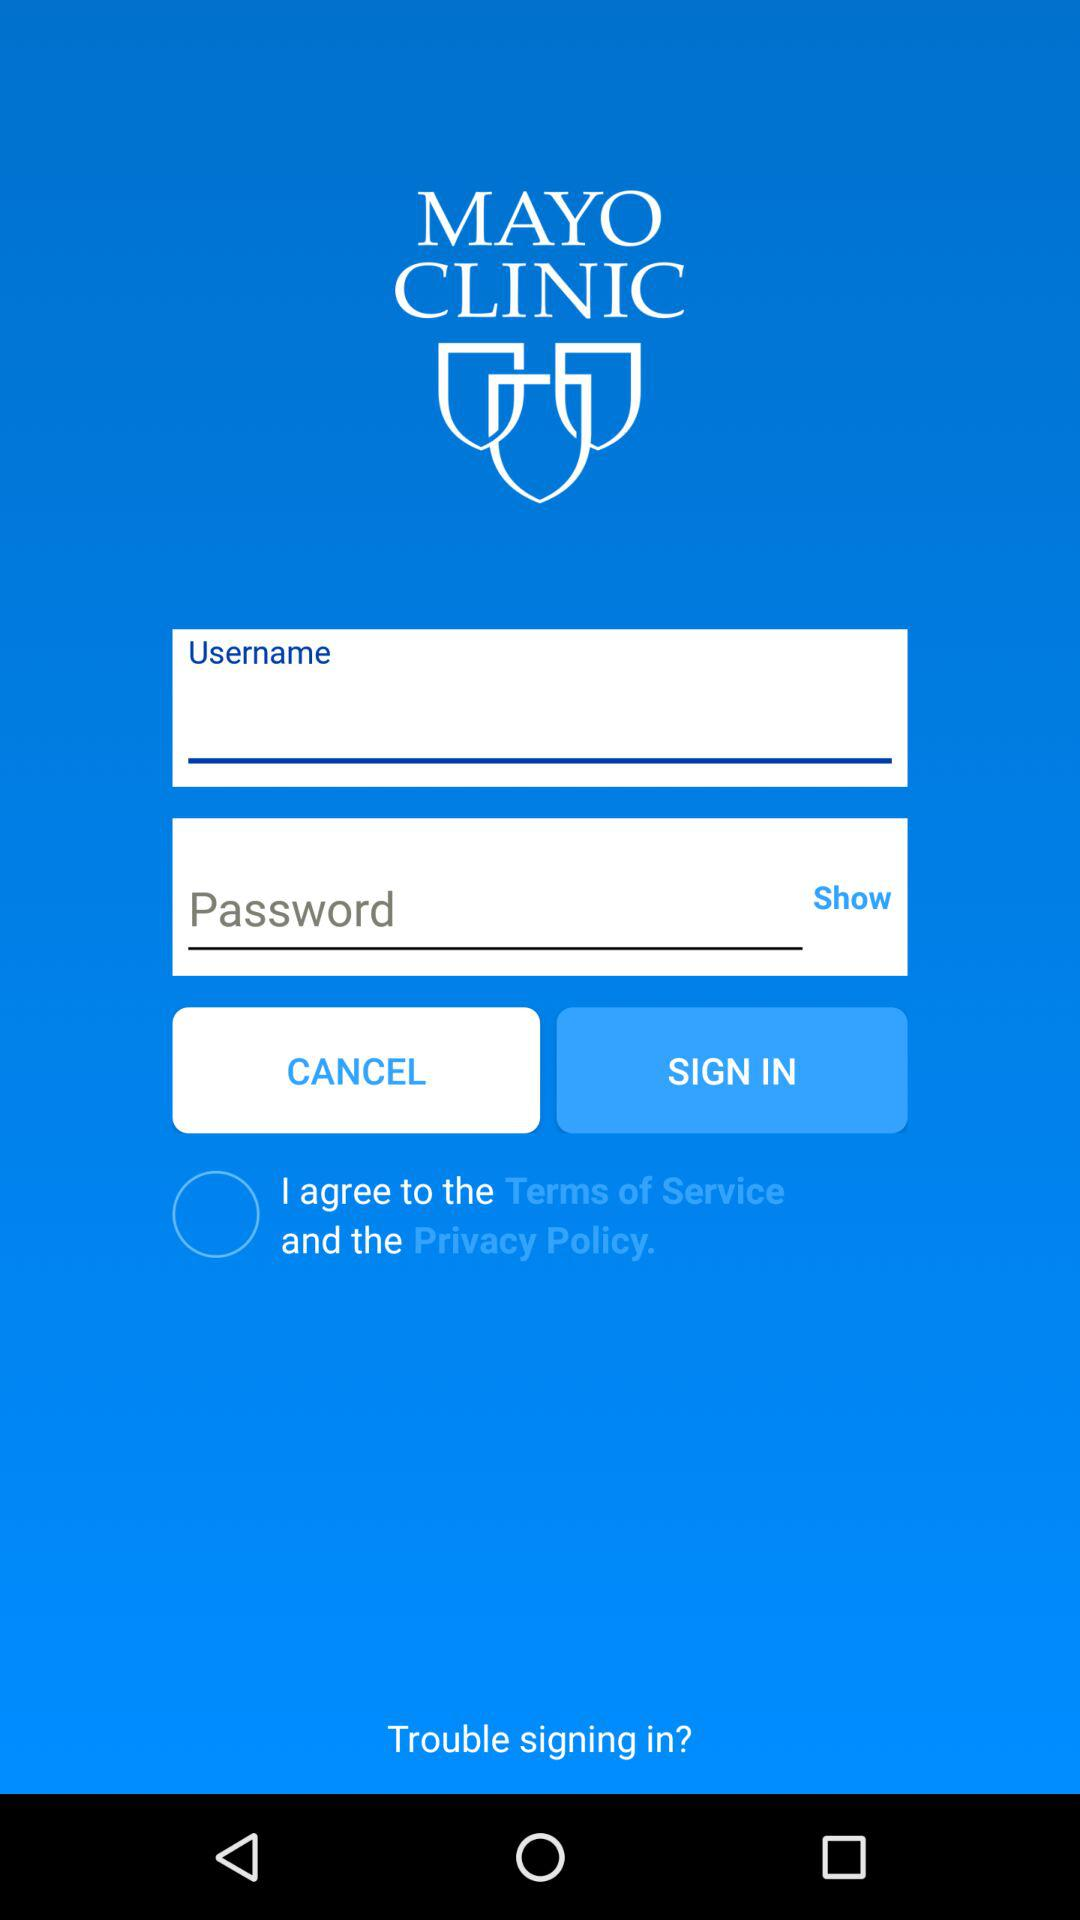What is the status of the option that includes agreement to the “Privacy Policy"? The status of the option that includes agreement to the "Privacy Policy" is "off". 